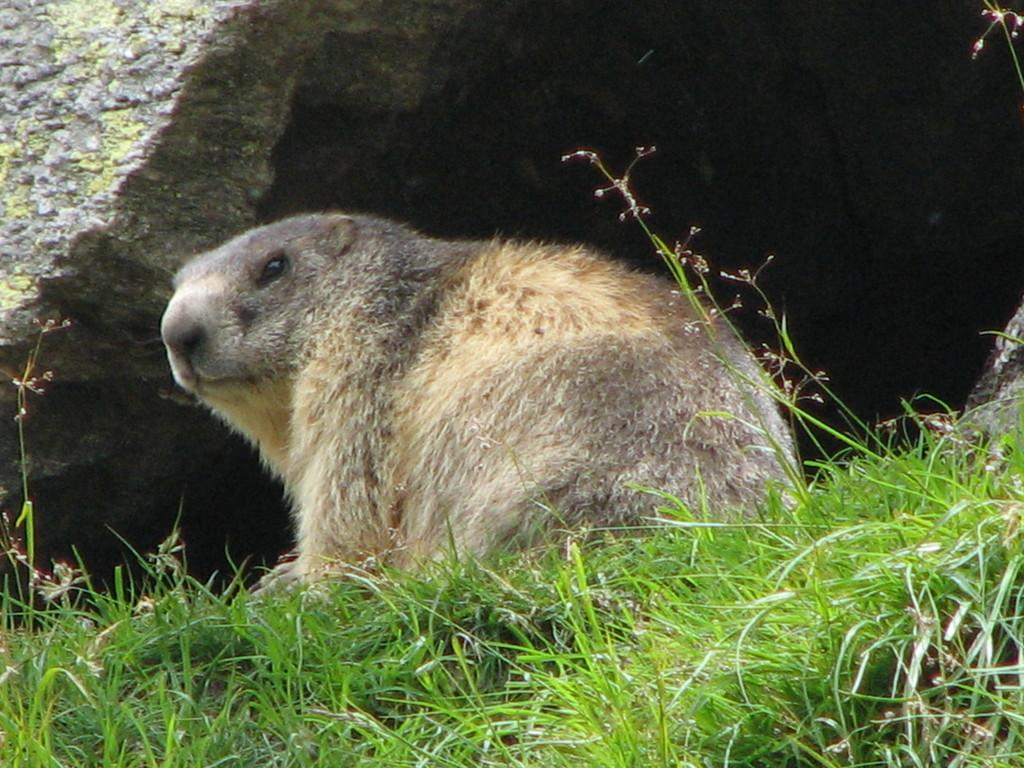What type of animal is in the image? There is an animal in the image, but the specific type cannot be determined from the provided facts. What type of vegetation is in the image? There is grass in the image. What geological feature is in the background of the image? There is a rock in the background of the image. How loud is the kitty crying in the image? There is no kitty present in the image, and therefore no crying can be heard or observed. 